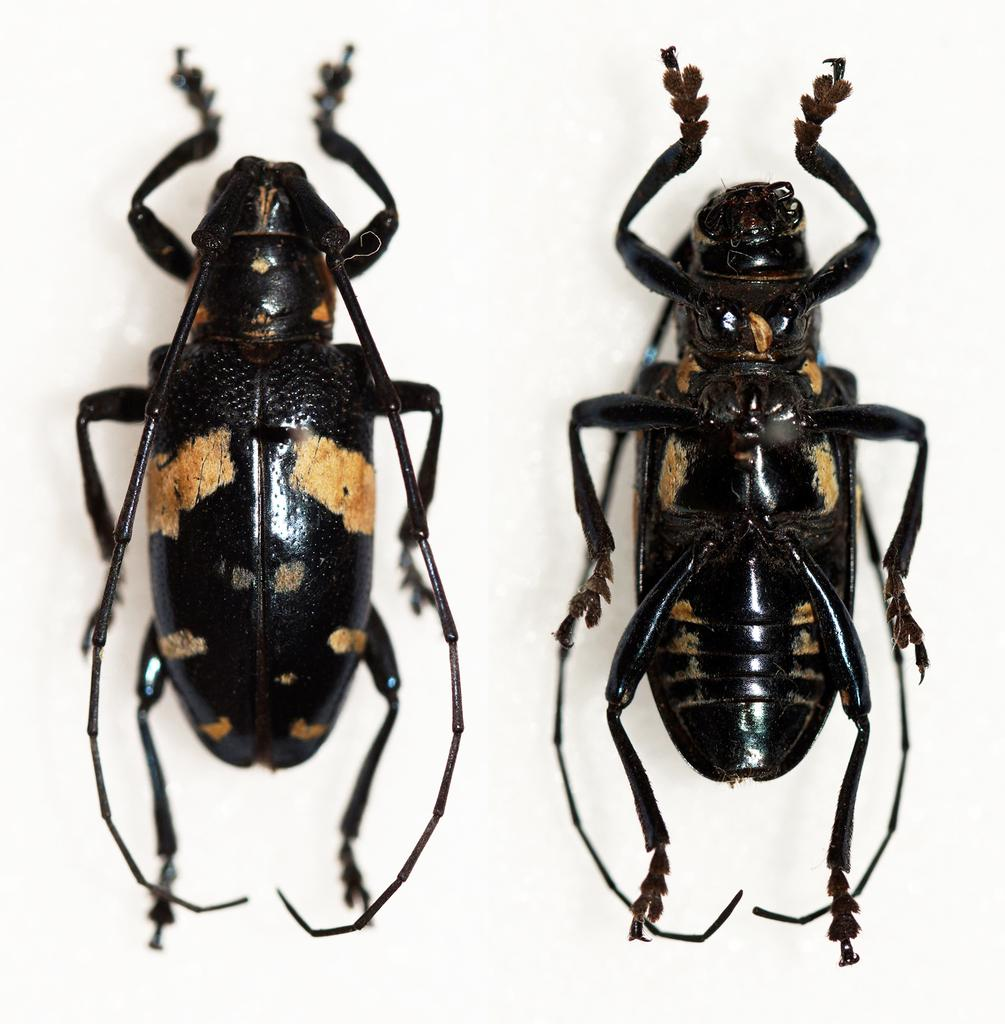What type of creatures can be seen in the image? There are insects in the image. What is the color of the surface on which the insects are located? The insects are on a white surface. What type of jewel is being transported by the carriage in the image? There is no carriage or jewel present in the image; it only features insects on a white surface. 